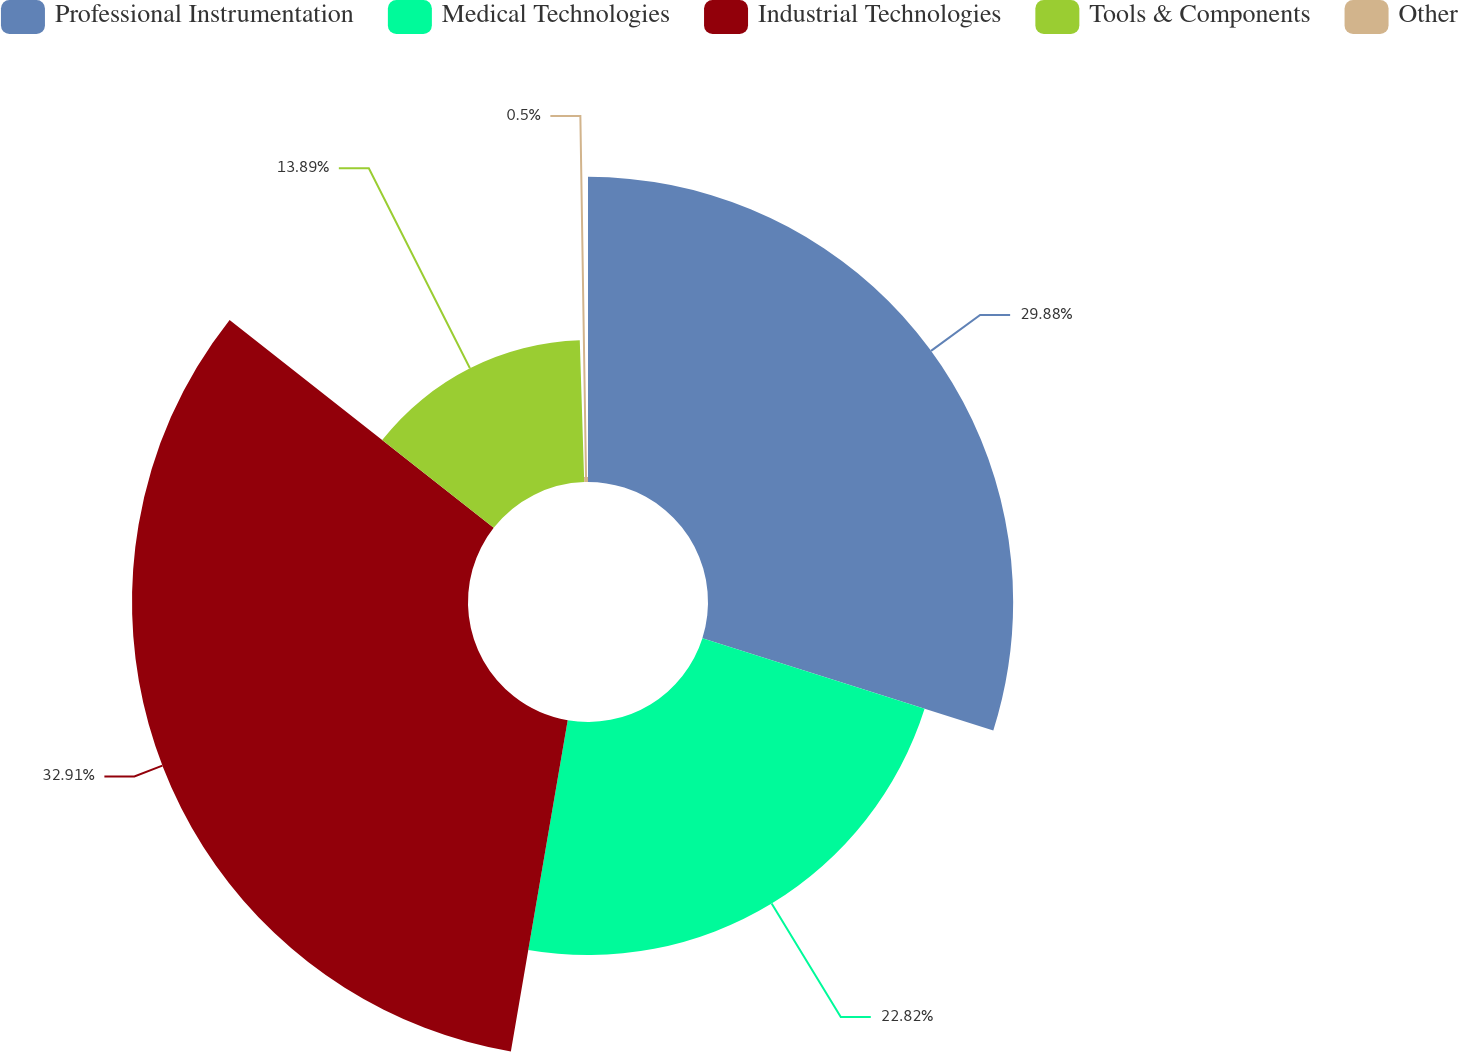<chart> <loc_0><loc_0><loc_500><loc_500><pie_chart><fcel>Professional Instrumentation<fcel>Medical Technologies<fcel>Industrial Technologies<fcel>Tools & Components<fcel>Other<nl><fcel>29.88%<fcel>22.82%<fcel>32.9%<fcel>13.89%<fcel>0.5%<nl></chart> 